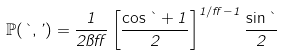Convert formula to latex. <formula><loc_0><loc_0><loc_500><loc_500>\mathbb { P } ( \theta , \varphi ) = \frac { 1 } { 2 \pi \alpha } \left [ \frac { \cos \theta + 1 } { 2 } \right ] ^ { 1 / \alpha - 1 } \frac { \sin \theta } { 2 }</formula> 